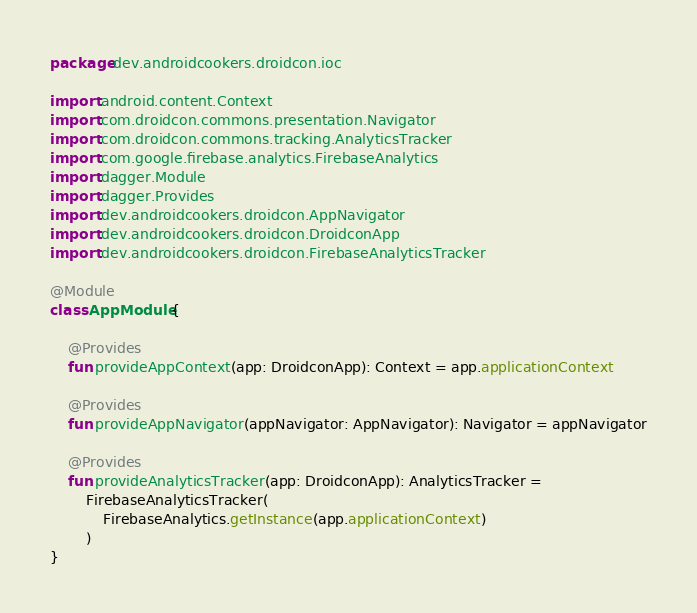Convert code to text. <code><loc_0><loc_0><loc_500><loc_500><_Kotlin_>package dev.androidcookers.droidcon.ioc

import android.content.Context
import com.droidcon.commons.presentation.Navigator
import com.droidcon.commons.tracking.AnalyticsTracker
import com.google.firebase.analytics.FirebaseAnalytics
import dagger.Module
import dagger.Provides
import dev.androidcookers.droidcon.AppNavigator
import dev.androidcookers.droidcon.DroidconApp
import dev.androidcookers.droidcon.FirebaseAnalyticsTracker

@Module
class AppModule {

    @Provides
    fun provideAppContext(app: DroidconApp): Context = app.applicationContext

    @Provides
    fun provideAppNavigator(appNavigator: AppNavigator): Navigator = appNavigator

    @Provides
    fun provideAnalyticsTracker(app: DroidconApp): AnalyticsTracker =
        FirebaseAnalyticsTracker(
            FirebaseAnalytics.getInstance(app.applicationContext)
        )
}</code> 